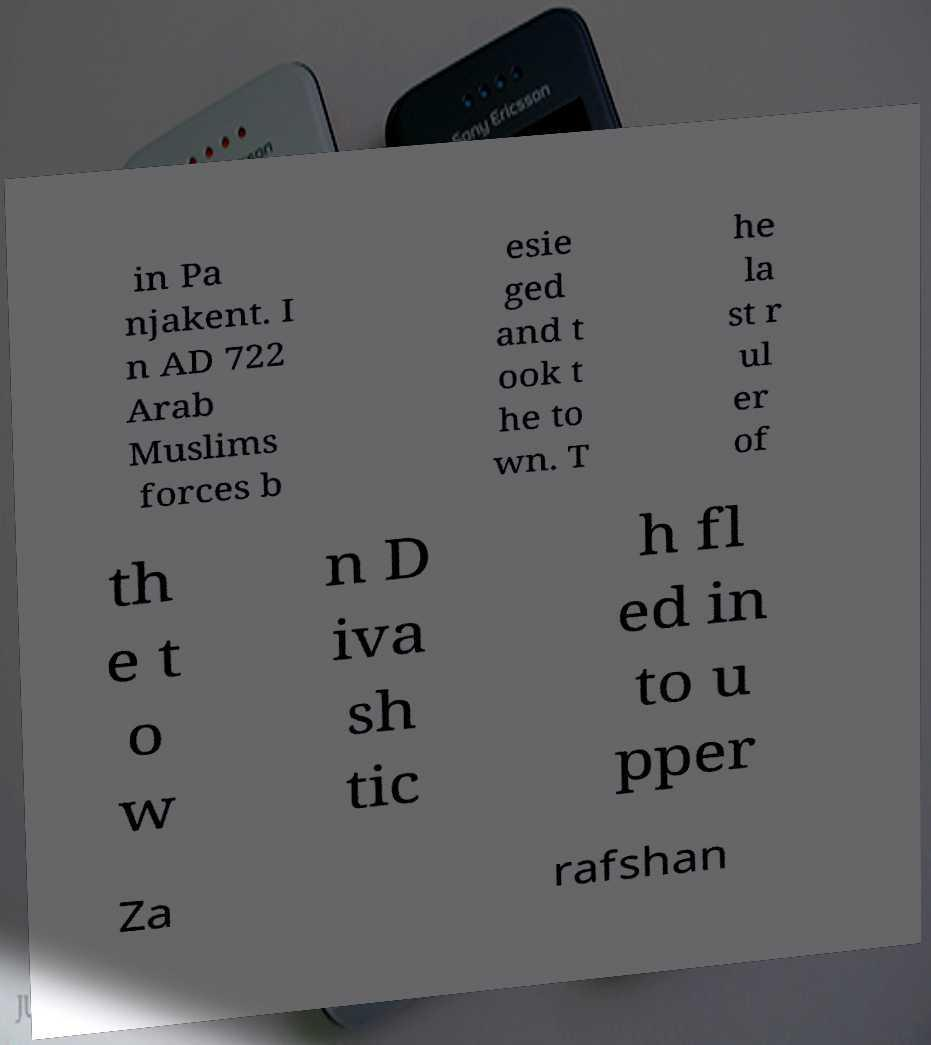Can you accurately transcribe the text from the provided image for me? in Pa njakent. I n AD 722 Arab Muslims forces b esie ged and t ook t he to wn. T he la st r ul er of th e t o w n D iva sh tic h fl ed in to u pper Za rafshan 